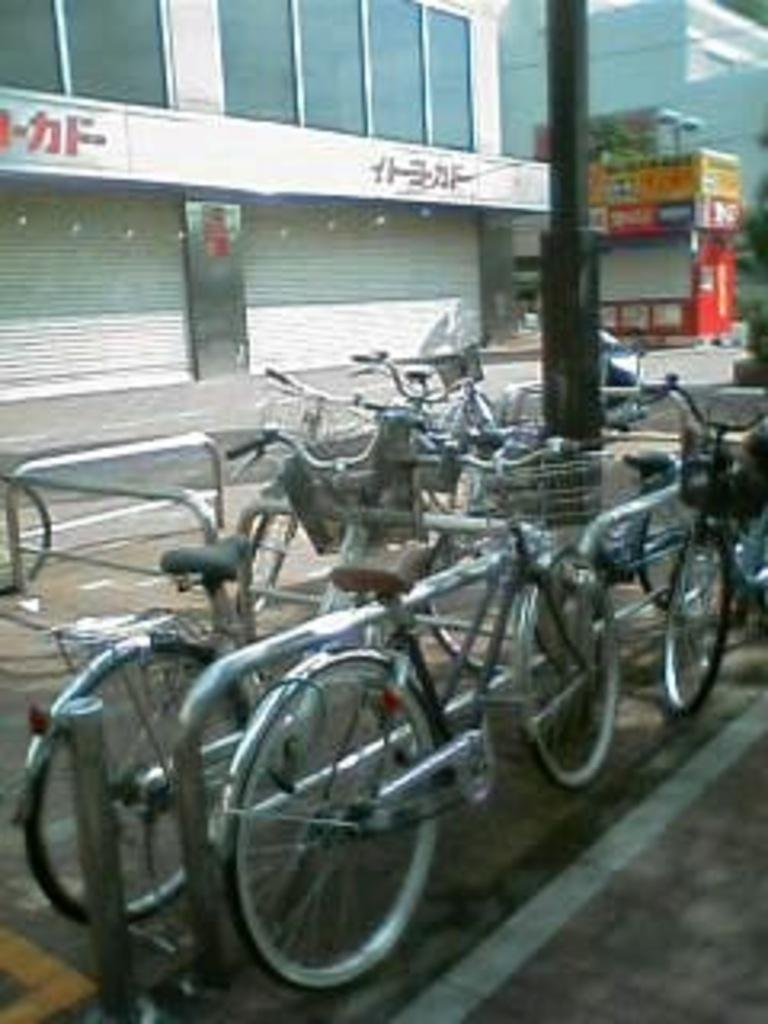What can be seen at the bottom of the image? There are cycles and a pole at the bottom of the image. What is visible in the background of the image? There are buildings and shutters in the background of the image. What type of pathway is present at the bottom of the image? There is a road at the bottom of the image. Can you tell me how many people are kissing in the image? There are no people kissing in the image; it only features cycles, a pole, buildings, shutters, and a road. What type of class is being taught in the image? There is no class present in the image. 